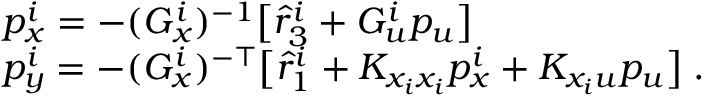Convert formula to latex. <formula><loc_0><loc_0><loc_500><loc_500>\begin{array} { r l } & { p _ { x } ^ { i } = - ( G _ { x } ^ { i } ) ^ { - 1 } \left [ \hat { r } _ { 3 } ^ { i } + G _ { u } ^ { i } p _ { u } \right ] } \\ & { p _ { y } ^ { i } = - ( G _ { x } ^ { i } ) ^ { - \top } \left [ \hat { r } _ { 1 } ^ { i } + K _ { x _ { i } x _ { i } } p _ { x } ^ { i } + K _ { x _ { i } u } p _ { u } \right ] \, . } \end{array}</formula> 